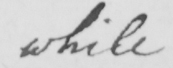Can you read and transcribe this handwriting? while 